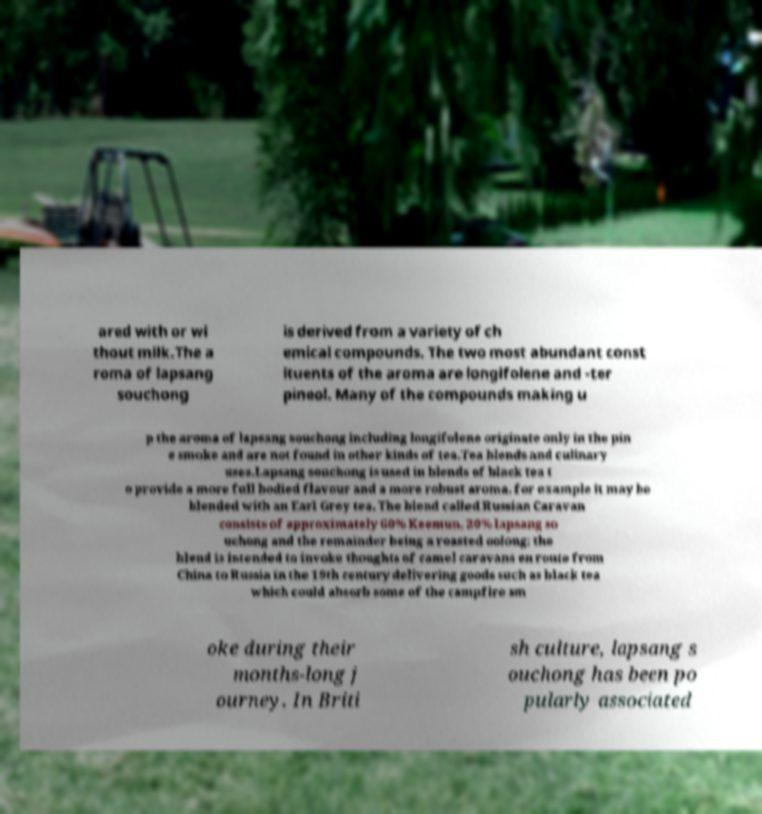Please identify and transcribe the text found in this image. ared with or wi thout milk.The a roma of lapsang souchong is derived from a variety of ch emical compounds. The two most abundant const ituents of the aroma are longifolene and -ter pineol. Many of the compounds making u p the aroma of lapsang souchong including longifolene originate only in the pin e smoke and are not found in other kinds of tea.Tea blends and culinary uses.Lapsang souchong is used in blends of black tea t o provide a more full bodied flavour and a more robust aroma, for example it may be blended with an Earl Grey tea. The blend called Russian Caravan consists of approximately 60% Keemun, 20% lapsang so uchong and the remainder being a roasted oolong; the blend is intended to invoke thoughts of camel caravans en route from China to Russia in the 19th century delivering goods such as black tea which could absorb some of the campfire sm oke during their months-long j ourney. In Briti sh culture, lapsang s ouchong has been po pularly associated 